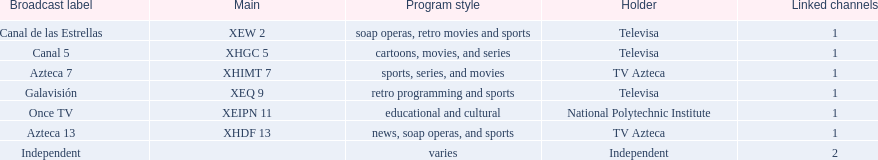What television stations are in morelos? Canal de las Estrellas, Canal 5, Azteca 7, Galavisión, Once TV, Azteca 13, Independent. Of those which network is owned by national polytechnic institute? Once TV. 